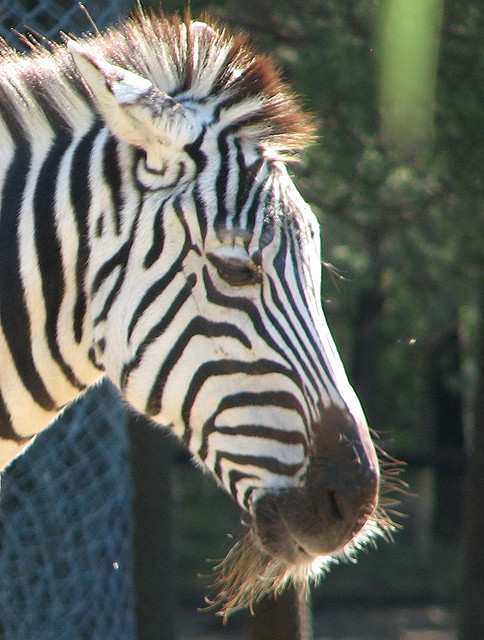<image>What species Zebra is this? It is unknown what species of Zebra this is. It could be an African Zebra or another unknown species. What species Zebra is this? I don't know what species of zebra this is. It can be an african zebra. 